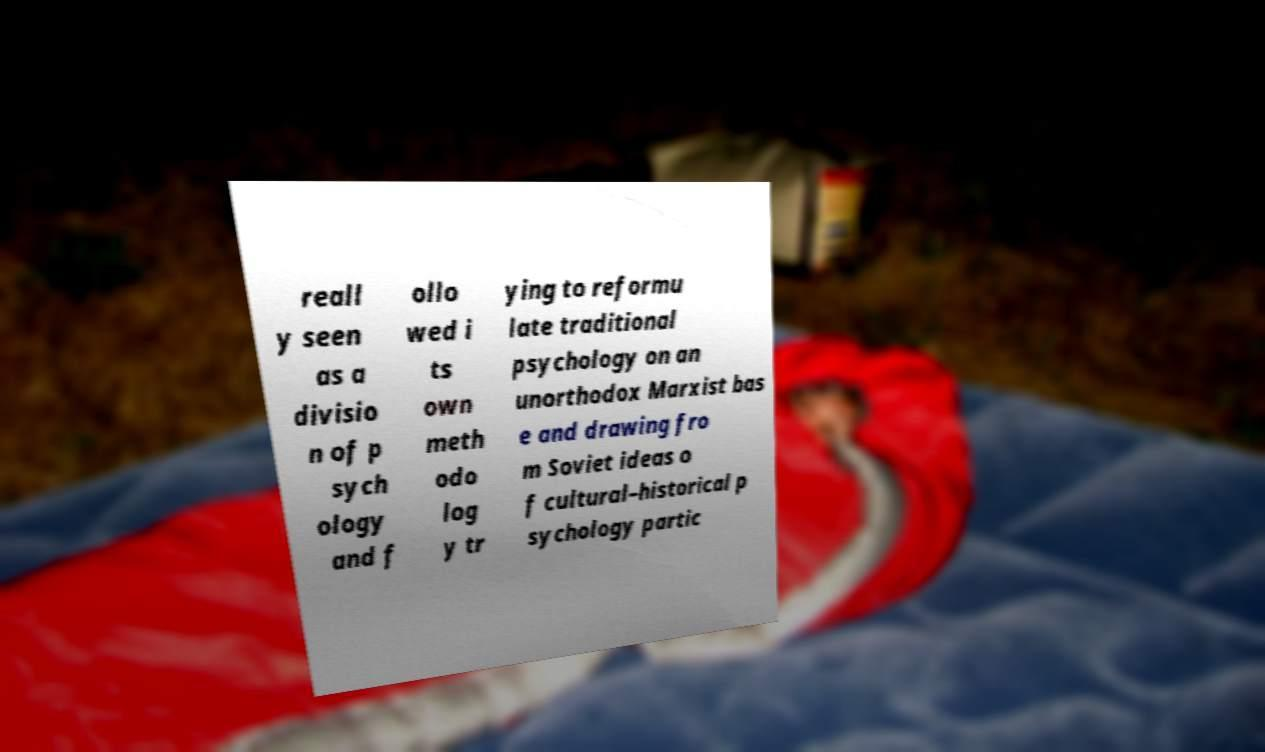For documentation purposes, I need the text within this image transcribed. Could you provide that? reall y seen as a divisio n of p sych ology and f ollo wed i ts own meth odo log y tr ying to reformu late traditional psychology on an unorthodox Marxist bas e and drawing fro m Soviet ideas o f cultural–historical p sychology partic 